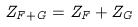Convert formula to latex. <formula><loc_0><loc_0><loc_500><loc_500>Z _ { F + G } = Z _ { F } + Z _ { G }</formula> 